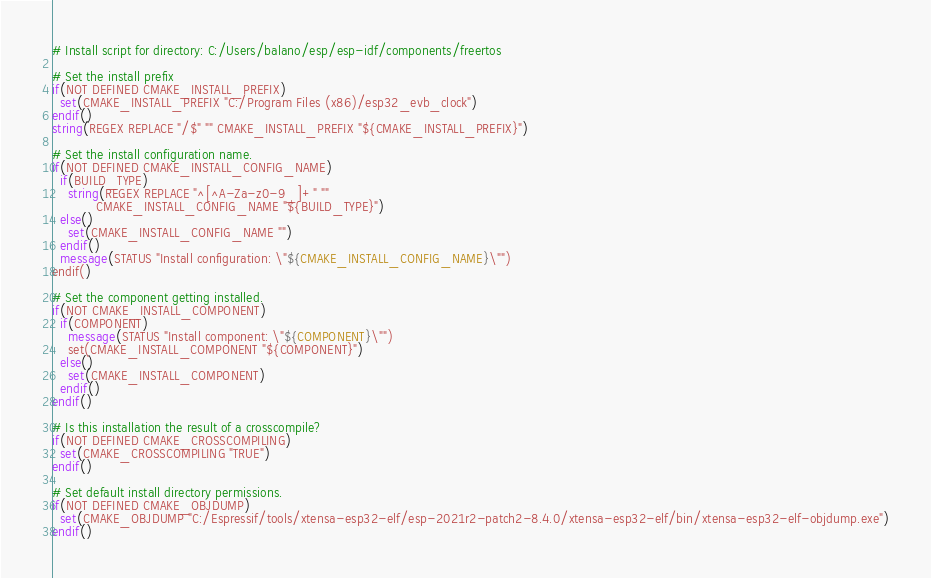<code> <loc_0><loc_0><loc_500><loc_500><_CMake_># Install script for directory: C:/Users/balano/esp/esp-idf/components/freertos

# Set the install prefix
if(NOT DEFINED CMAKE_INSTALL_PREFIX)
  set(CMAKE_INSTALL_PREFIX "C:/Program Files (x86)/esp32_evb_clock")
endif()
string(REGEX REPLACE "/$" "" CMAKE_INSTALL_PREFIX "${CMAKE_INSTALL_PREFIX}")

# Set the install configuration name.
if(NOT DEFINED CMAKE_INSTALL_CONFIG_NAME)
  if(BUILD_TYPE)
    string(REGEX REPLACE "^[^A-Za-z0-9_]+" ""
           CMAKE_INSTALL_CONFIG_NAME "${BUILD_TYPE}")
  else()
    set(CMAKE_INSTALL_CONFIG_NAME "")
  endif()
  message(STATUS "Install configuration: \"${CMAKE_INSTALL_CONFIG_NAME}\"")
endif()

# Set the component getting installed.
if(NOT CMAKE_INSTALL_COMPONENT)
  if(COMPONENT)
    message(STATUS "Install component: \"${COMPONENT}\"")
    set(CMAKE_INSTALL_COMPONENT "${COMPONENT}")
  else()
    set(CMAKE_INSTALL_COMPONENT)
  endif()
endif()

# Is this installation the result of a crosscompile?
if(NOT DEFINED CMAKE_CROSSCOMPILING)
  set(CMAKE_CROSSCOMPILING "TRUE")
endif()

# Set default install directory permissions.
if(NOT DEFINED CMAKE_OBJDUMP)
  set(CMAKE_OBJDUMP "C:/Espressif/tools/xtensa-esp32-elf/esp-2021r2-patch2-8.4.0/xtensa-esp32-elf/bin/xtensa-esp32-elf-objdump.exe")
endif()

</code> 